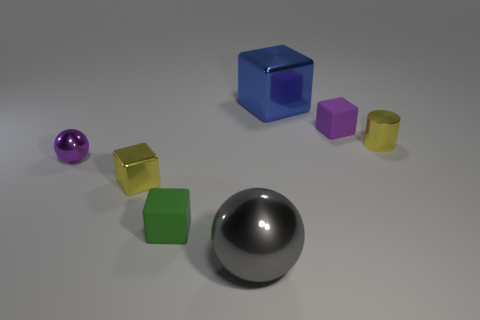Add 2 small shiny cylinders. How many objects exist? 9 Subtract all small shiny cubes. How many cubes are left? 3 Subtract all purple spheres. How many spheres are left? 1 Subtract all blocks. How many objects are left? 3 Subtract all green cubes. How many gray spheres are left? 1 Subtract all tiny purple spheres. Subtract all small yellow metallic objects. How many objects are left? 4 Add 7 tiny purple metallic things. How many tiny purple metallic things are left? 8 Add 4 purple metal things. How many purple metal things exist? 5 Subtract 0 brown spheres. How many objects are left? 7 Subtract 2 spheres. How many spheres are left? 0 